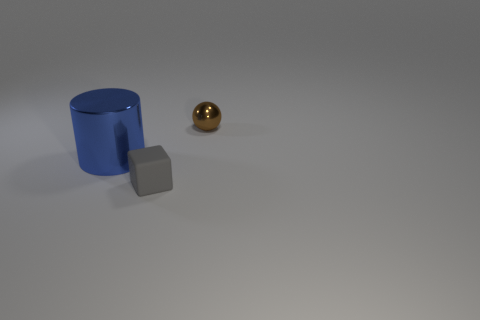What is the object that is both in front of the tiny brown metallic sphere and to the right of the large blue object made of?
Keep it short and to the point. Rubber. There is a small thing that is to the left of the brown ball; what is its material?
Provide a succinct answer. Rubber. There is a large thing that is the same material as the tiny brown ball; what is its color?
Offer a terse response. Blue. Are there any tiny matte cubes on the left side of the tiny sphere?
Make the answer very short. Yes. Is the size of the shiny ball the same as the shiny thing that is to the left of the block?
Provide a short and direct response. No. Is there another blue object of the same shape as the big blue shiny object?
Ensure brevity in your answer.  No. There is a thing that is on the left side of the brown shiny object and behind the cube; what shape is it?
Offer a terse response. Cylinder. What number of large blue objects are made of the same material as the small brown object?
Give a very brief answer. 1. Is the number of big blue shiny objects that are to the right of the gray object less than the number of large blue shiny cylinders?
Keep it short and to the point. Yes. Are there any big cylinders that are left of the metal thing that is in front of the metal ball?
Give a very brief answer. No. 